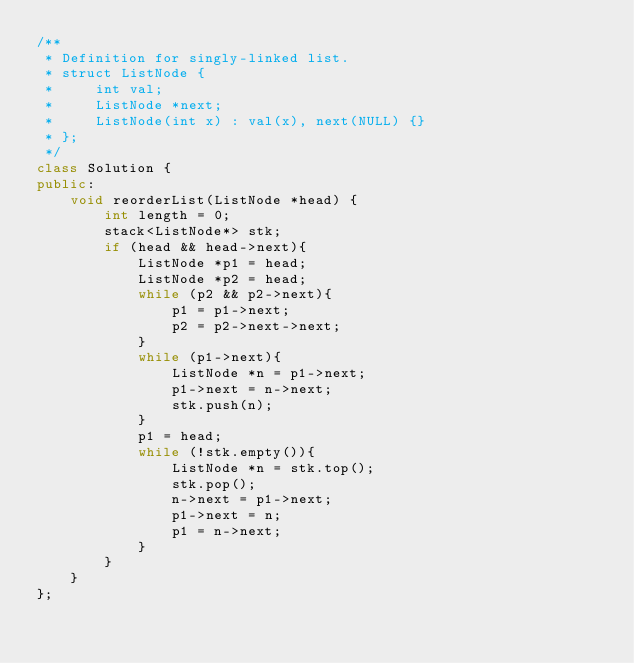Convert code to text. <code><loc_0><loc_0><loc_500><loc_500><_C++_>/**
 * Definition for singly-linked list.
 * struct ListNode {
 *     int val;
 *     ListNode *next;
 *     ListNode(int x) : val(x), next(NULL) {}
 * };
 */
class Solution {
public:
    void reorderList(ListNode *head) {
        int length = 0;
        stack<ListNode*> stk;
        if (head && head->next){
            ListNode *p1 = head;
            ListNode *p2 = head;
            while (p2 && p2->next){
                p1 = p1->next;
                p2 = p2->next->next;
            }
            while (p1->next){
                ListNode *n = p1->next;
                p1->next = n->next;
                stk.push(n);
            }
            p1 = head;
            while (!stk.empty()){
                ListNode *n = stk.top();
                stk.pop();
                n->next = p1->next;
                p1->next = n;
                p1 = n->next;
            }
        }
    }
};</code> 